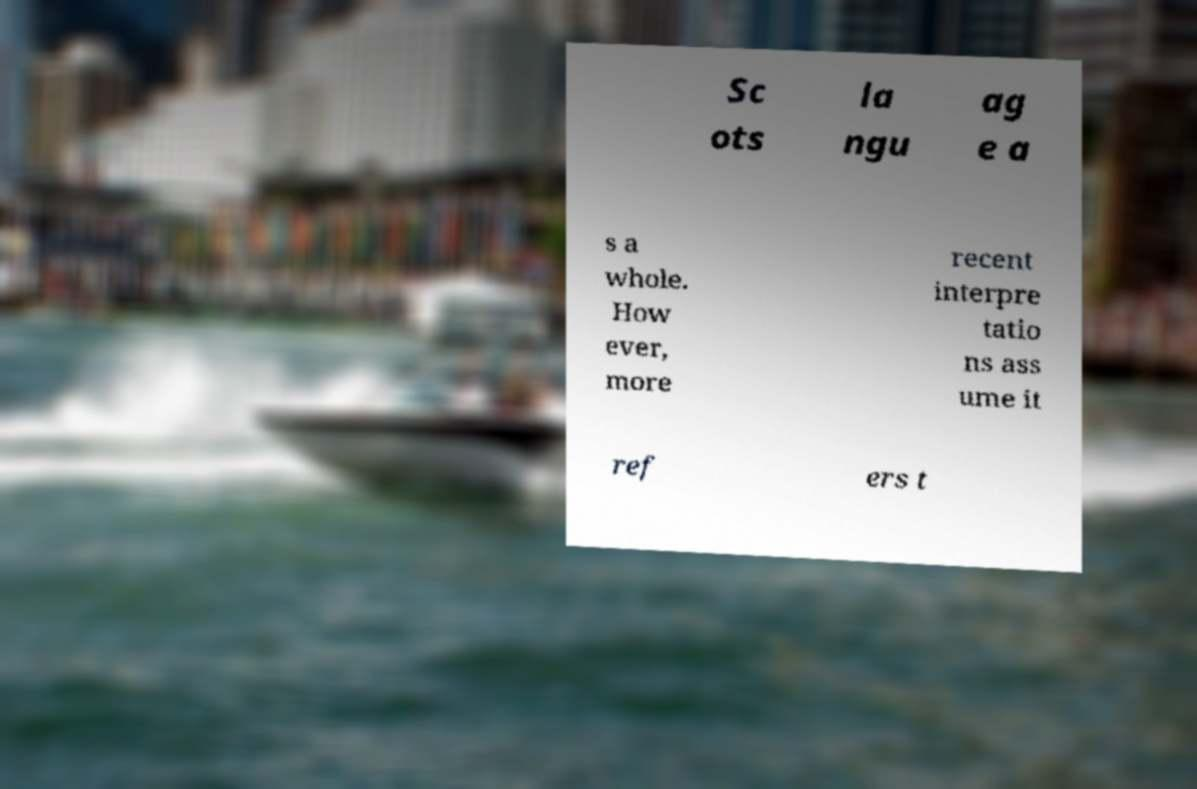Could you assist in decoding the text presented in this image and type it out clearly? Sc ots la ngu ag e a s a whole. How ever, more recent interpre tatio ns ass ume it ref ers t 